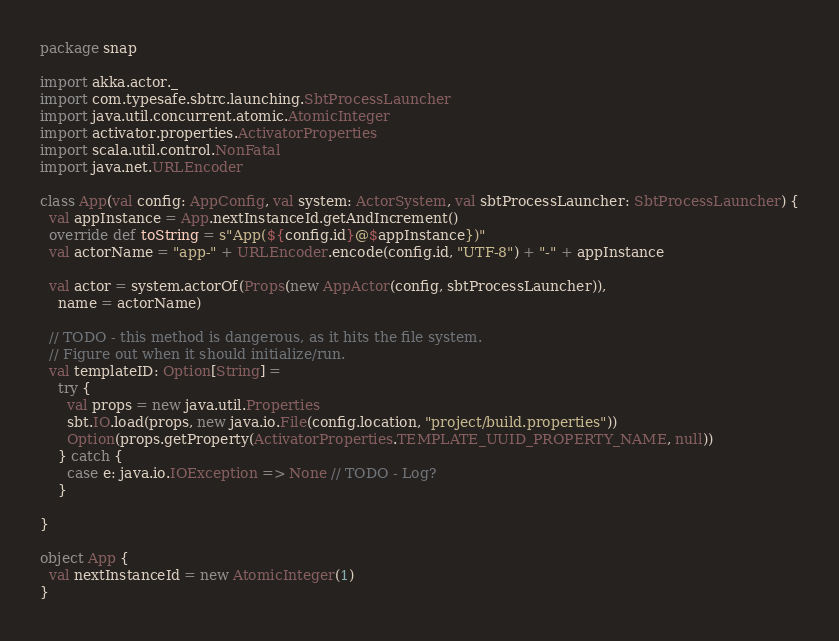Convert code to text. <code><loc_0><loc_0><loc_500><loc_500><_Scala_>package snap

import akka.actor._
import com.typesafe.sbtrc.launching.SbtProcessLauncher
import java.util.concurrent.atomic.AtomicInteger
import activator.properties.ActivatorProperties
import scala.util.control.NonFatal
import java.net.URLEncoder

class App(val config: AppConfig, val system: ActorSystem, val sbtProcessLauncher: SbtProcessLauncher) {
  val appInstance = App.nextInstanceId.getAndIncrement()
  override def toString = s"App(${config.id}@$appInstance})"
  val actorName = "app-" + URLEncoder.encode(config.id, "UTF-8") + "-" + appInstance

  val actor = system.actorOf(Props(new AppActor(config, sbtProcessLauncher)),
    name = actorName)

  // TODO - this method is dangerous, as it hits the file system.
  // Figure out when it should initialize/run.
  val templateID: Option[String] =
    try {
      val props = new java.util.Properties
      sbt.IO.load(props, new java.io.File(config.location, "project/build.properties"))
      Option(props.getProperty(ActivatorProperties.TEMPLATE_UUID_PROPERTY_NAME, null))
    } catch {
      case e: java.io.IOException => None // TODO - Log?
    }

}

object App {
  val nextInstanceId = new AtomicInteger(1)
}
</code> 